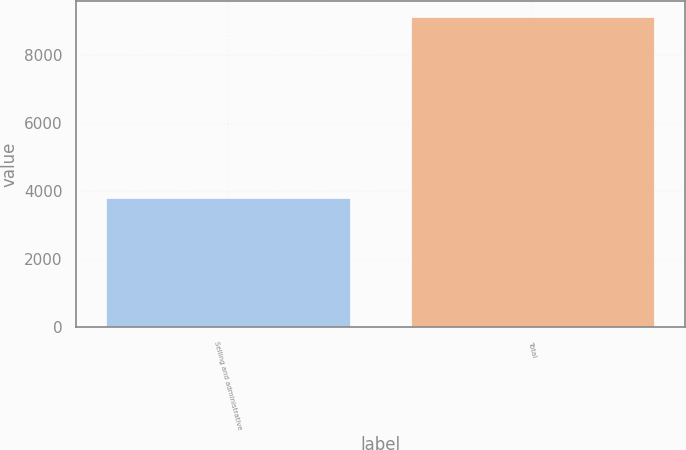<chart> <loc_0><loc_0><loc_500><loc_500><bar_chart><fcel>Selling and administrative<fcel>Total<nl><fcel>3798<fcel>9118<nl></chart> 